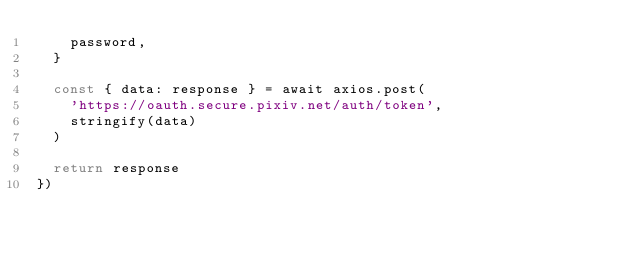Convert code to text. <code><loc_0><loc_0><loc_500><loc_500><_JavaScript_>    password,
  }

  const { data: response } = await axios.post(
    'https://oauth.secure.pixiv.net/auth/token',
    stringify(data)
  )

  return response
})
</code> 